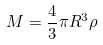Convert formula to latex. <formula><loc_0><loc_0><loc_500><loc_500>M = \frac { 4 } { 3 } \pi R ^ { 3 } \rho</formula> 